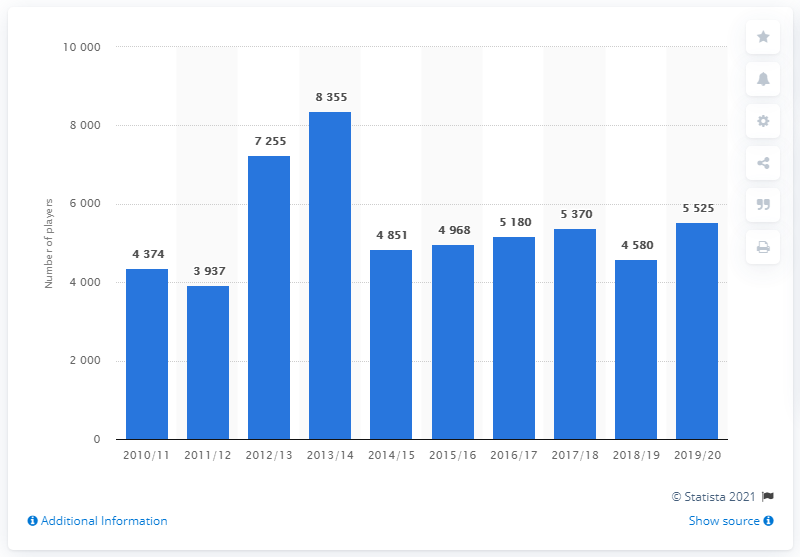Point out several critical features in this image. The number of registered players underwent the most significant change in 2014/2015. The year 2013/14 reached the highest bar value. 